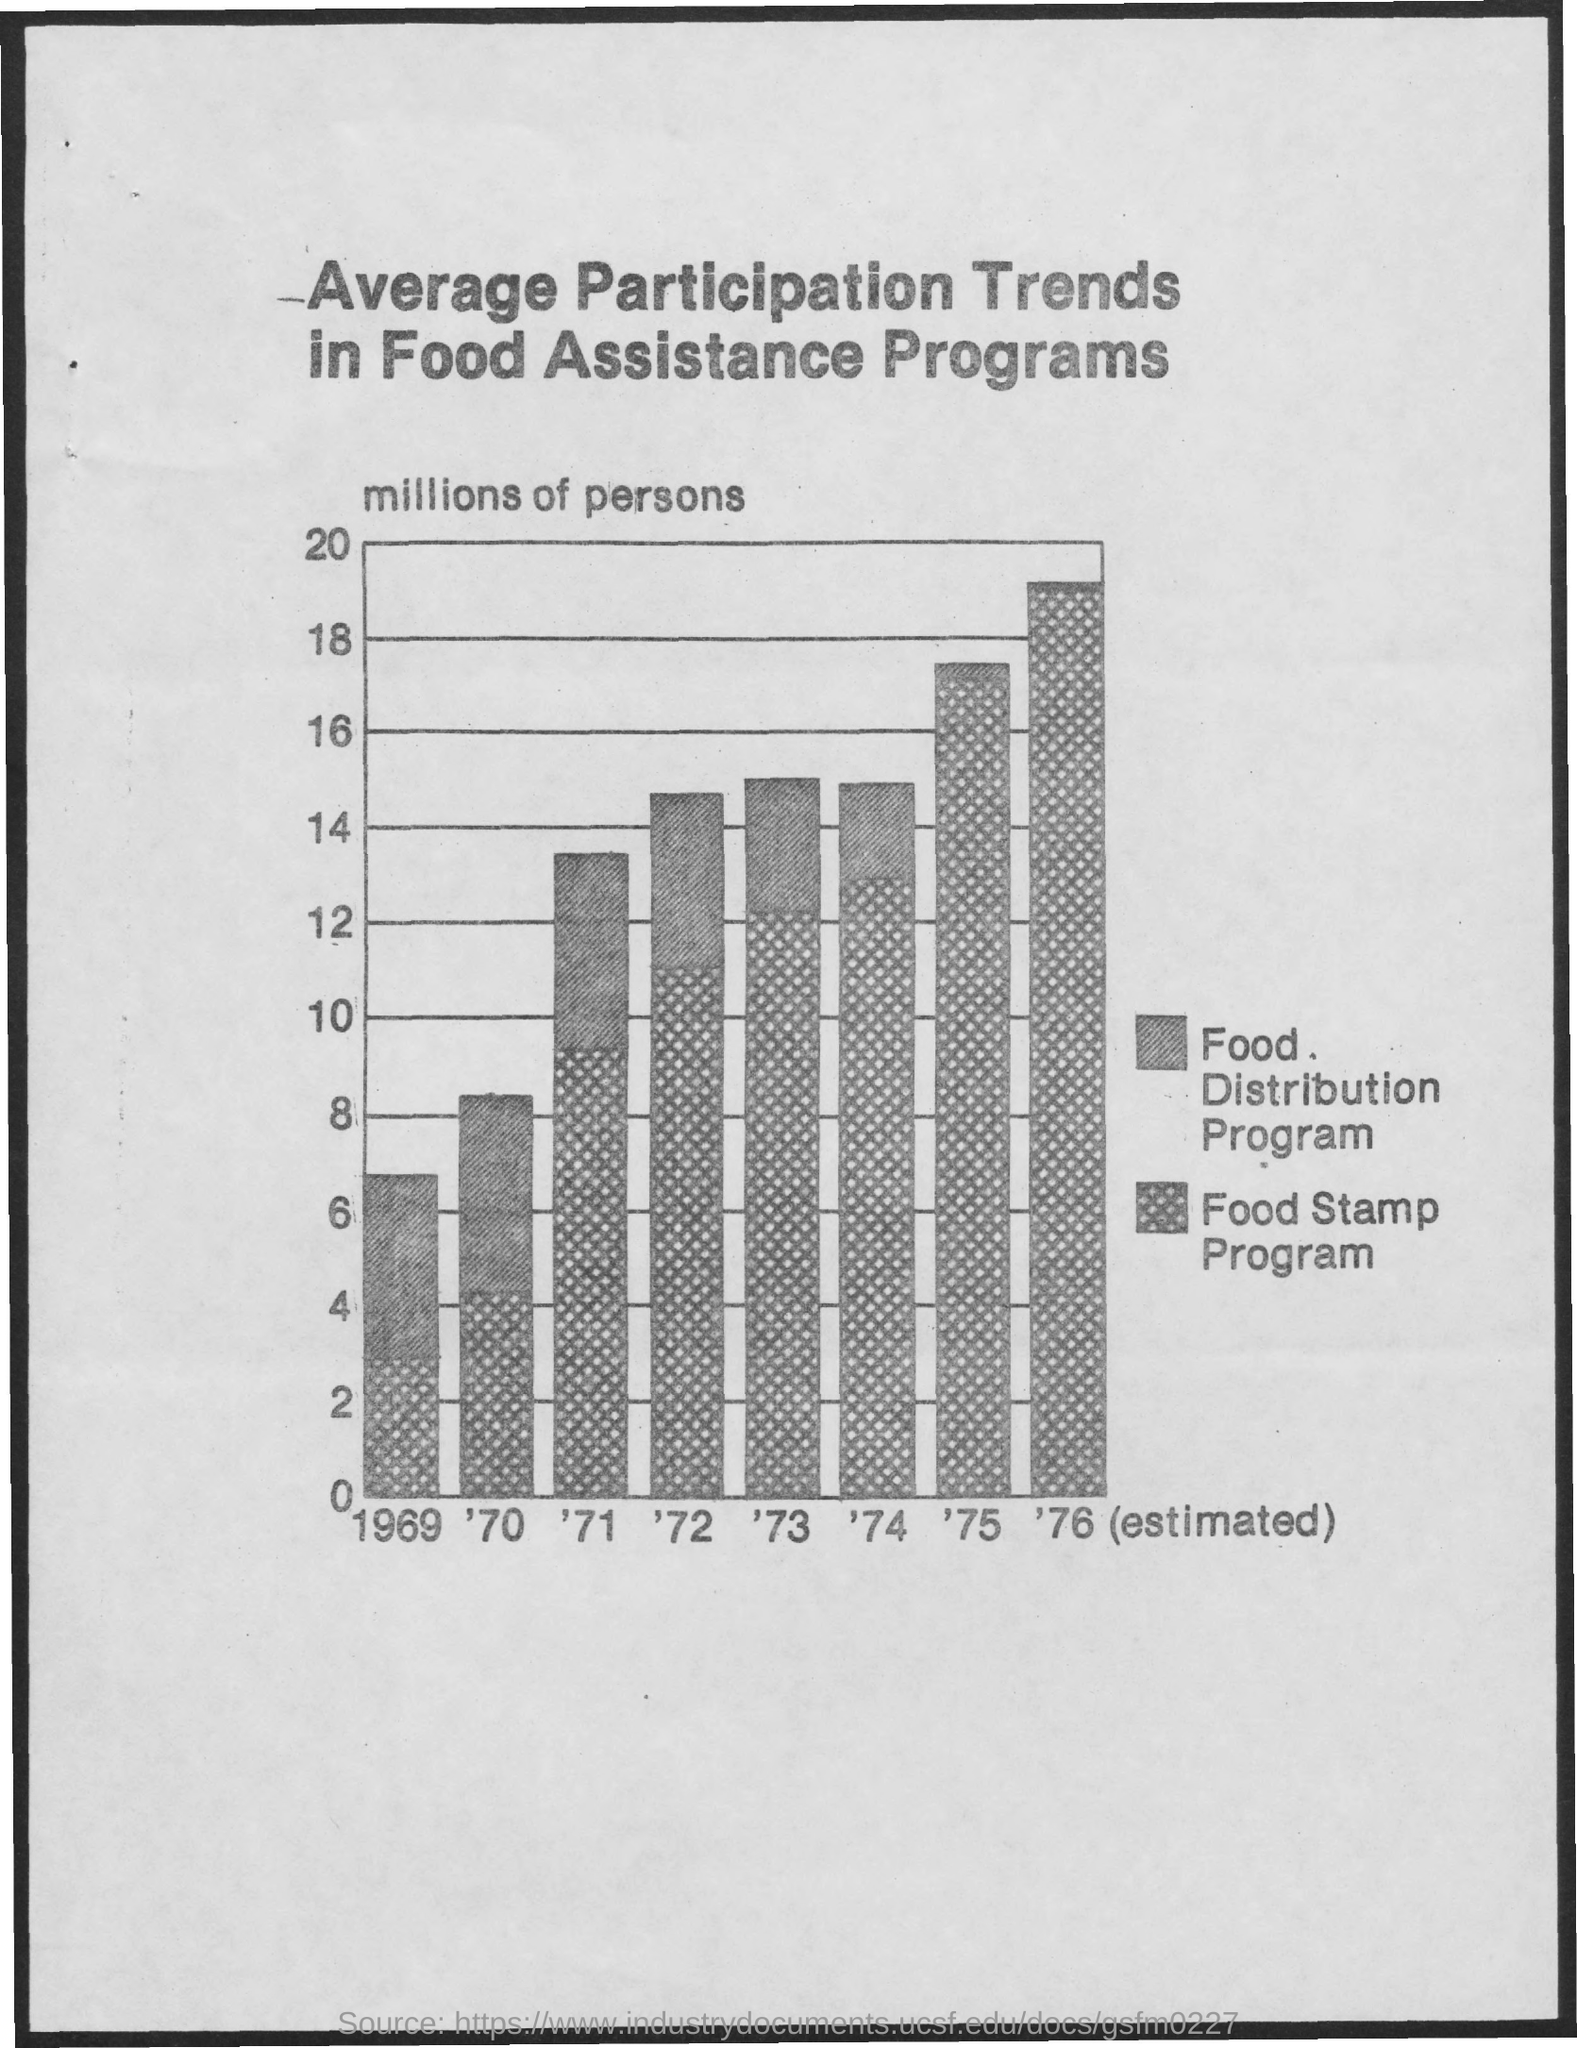What is the title of the document?
Keep it short and to the point. Average participation trends in food assistance programs. Food Stamp Program is maximum in which year?
Provide a short and direct response. '76. Food Stamp Program is minimum in which year?
Provide a succinct answer. 1969. 